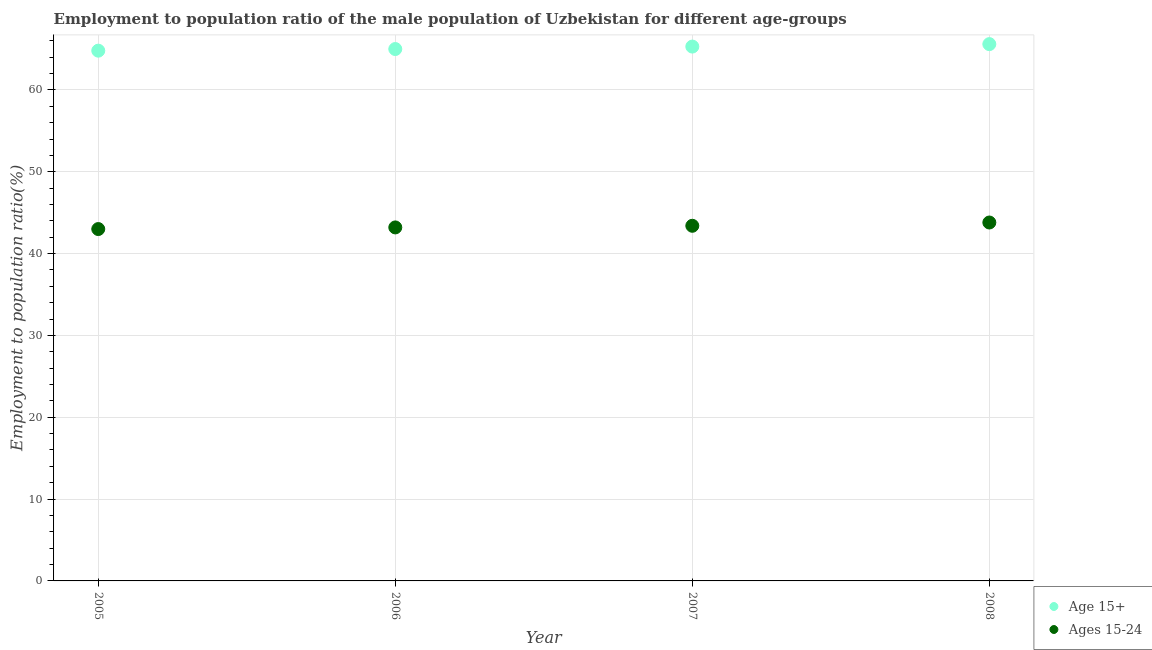How many different coloured dotlines are there?
Give a very brief answer. 2. What is the employment to population ratio(age 15+) in 2008?
Provide a succinct answer. 65.6. Across all years, what is the maximum employment to population ratio(age 15+)?
Offer a very short reply. 65.6. Across all years, what is the minimum employment to population ratio(age 15+)?
Make the answer very short. 64.8. What is the total employment to population ratio(age 15+) in the graph?
Your answer should be very brief. 260.7. What is the difference between the employment to population ratio(age 15-24) in 2006 and that in 2008?
Provide a short and direct response. -0.6. What is the difference between the employment to population ratio(age 15+) in 2007 and the employment to population ratio(age 15-24) in 2008?
Your response must be concise. 21.5. What is the average employment to population ratio(age 15+) per year?
Your response must be concise. 65.18. In the year 2007, what is the difference between the employment to population ratio(age 15+) and employment to population ratio(age 15-24)?
Provide a short and direct response. 21.9. In how many years, is the employment to population ratio(age 15-24) greater than 16 %?
Offer a very short reply. 4. What is the ratio of the employment to population ratio(age 15-24) in 2007 to that in 2008?
Ensure brevity in your answer.  0.99. Is the difference between the employment to population ratio(age 15+) in 2006 and 2007 greater than the difference between the employment to population ratio(age 15-24) in 2006 and 2007?
Provide a short and direct response. No. What is the difference between the highest and the second highest employment to population ratio(age 15+)?
Your response must be concise. 0.3. What is the difference between the highest and the lowest employment to population ratio(age 15-24)?
Your answer should be compact. 0.8. In how many years, is the employment to population ratio(age 15-24) greater than the average employment to population ratio(age 15-24) taken over all years?
Give a very brief answer. 2. Does the employment to population ratio(age 15+) monotonically increase over the years?
Your answer should be very brief. Yes. How many dotlines are there?
Provide a succinct answer. 2. How many legend labels are there?
Give a very brief answer. 2. What is the title of the graph?
Make the answer very short. Employment to population ratio of the male population of Uzbekistan for different age-groups. What is the Employment to population ratio(%) in Age 15+ in 2005?
Give a very brief answer. 64.8. What is the Employment to population ratio(%) of Ages 15-24 in 2005?
Your answer should be compact. 43. What is the Employment to population ratio(%) of Age 15+ in 2006?
Offer a terse response. 65. What is the Employment to population ratio(%) of Ages 15-24 in 2006?
Ensure brevity in your answer.  43.2. What is the Employment to population ratio(%) in Age 15+ in 2007?
Provide a short and direct response. 65.3. What is the Employment to population ratio(%) in Ages 15-24 in 2007?
Provide a succinct answer. 43.4. What is the Employment to population ratio(%) in Age 15+ in 2008?
Make the answer very short. 65.6. What is the Employment to population ratio(%) of Ages 15-24 in 2008?
Your answer should be compact. 43.8. Across all years, what is the maximum Employment to population ratio(%) of Age 15+?
Your response must be concise. 65.6. Across all years, what is the maximum Employment to population ratio(%) of Ages 15-24?
Provide a succinct answer. 43.8. Across all years, what is the minimum Employment to population ratio(%) in Age 15+?
Keep it short and to the point. 64.8. What is the total Employment to population ratio(%) of Age 15+ in the graph?
Give a very brief answer. 260.7. What is the total Employment to population ratio(%) of Ages 15-24 in the graph?
Give a very brief answer. 173.4. What is the difference between the Employment to population ratio(%) of Ages 15-24 in 2005 and that in 2006?
Your answer should be very brief. -0.2. What is the difference between the Employment to population ratio(%) of Age 15+ in 2005 and that in 2007?
Your answer should be compact. -0.5. What is the difference between the Employment to population ratio(%) in Ages 15-24 in 2005 and that in 2007?
Provide a succinct answer. -0.4. What is the difference between the Employment to population ratio(%) in Ages 15-24 in 2005 and that in 2008?
Your answer should be very brief. -0.8. What is the difference between the Employment to population ratio(%) in Age 15+ in 2007 and that in 2008?
Keep it short and to the point. -0.3. What is the difference between the Employment to population ratio(%) of Ages 15-24 in 2007 and that in 2008?
Ensure brevity in your answer.  -0.4. What is the difference between the Employment to population ratio(%) of Age 15+ in 2005 and the Employment to population ratio(%) of Ages 15-24 in 2006?
Make the answer very short. 21.6. What is the difference between the Employment to population ratio(%) of Age 15+ in 2005 and the Employment to population ratio(%) of Ages 15-24 in 2007?
Make the answer very short. 21.4. What is the difference between the Employment to population ratio(%) of Age 15+ in 2005 and the Employment to population ratio(%) of Ages 15-24 in 2008?
Keep it short and to the point. 21. What is the difference between the Employment to population ratio(%) of Age 15+ in 2006 and the Employment to population ratio(%) of Ages 15-24 in 2007?
Provide a succinct answer. 21.6. What is the difference between the Employment to population ratio(%) of Age 15+ in 2006 and the Employment to population ratio(%) of Ages 15-24 in 2008?
Your answer should be very brief. 21.2. What is the average Employment to population ratio(%) of Age 15+ per year?
Provide a succinct answer. 65.17. What is the average Employment to population ratio(%) in Ages 15-24 per year?
Your answer should be compact. 43.35. In the year 2005, what is the difference between the Employment to population ratio(%) in Age 15+ and Employment to population ratio(%) in Ages 15-24?
Your response must be concise. 21.8. In the year 2006, what is the difference between the Employment to population ratio(%) of Age 15+ and Employment to population ratio(%) of Ages 15-24?
Provide a short and direct response. 21.8. In the year 2007, what is the difference between the Employment to population ratio(%) in Age 15+ and Employment to population ratio(%) in Ages 15-24?
Provide a succinct answer. 21.9. In the year 2008, what is the difference between the Employment to population ratio(%) in Age 15+ and Employment to population ratio(%) in Ages 15-24?
Keep it short and to the point. 21.8. What is the ratio of the Employment to population ratio(%) in Age 15+ in 2005 to that in 2006?
Your response must be concise. 1. What is the ratio of the Employment to population ratio(%) in Ages 15-24 in 2005 to that in 2006?
Your answer should be very brief. 1. What is the ratio of the Employment to population ratio(%) in Ages 15-24 in 2005 to that in 2007?
Your response must be concise. 0.99. What is the ratio of the Employment to population ratio(%) in Age 15+ in 2005 to that in 2008?
Offer a very short reply. 0.99. What is the ratio of the Employment to population ratio(%) of Ages 15-24 in 2005 to that in 2008?
Keep it short and to the point. 0.98. What is the ratio of the Employment to population ratio(%) in Age 15+ in 2006 to that in 2007?
Offer a very short reply. 1. What is the ratio of the Employment to population ratio(%) in Ages 15-24 in 2006 to that in 2007?
Provide a short and direct response. 1. What is the ratio of the Employment to population ratio(%) in Age 15+ in 2006 to that in 2008?
Keep it short and to the point. 0.99. What is the ratio of the Employment to population ratio(%) in Ages 15-24 in 2006 to that in 2008?
Offer a terse response. 0.99. What is the ratio of the Employment to population ratio(%) of Age 15+ in 2007 to that in 2008?
Your answer should be very brief. 1. What is the ratio of the Employment to population ratio(%) of Ages 15-24 in 2007 to that in 2008?
Provide a succinct answer. 0.99. What is the difference between the highest and the second highest Employment to population ratio(%) of Age 15+?
Offer a terse response. 0.3. What is the difference between the highest and the lowest Employment to population ratio(%) of Age 15+?
Keep it short and to the point. 0.8. 